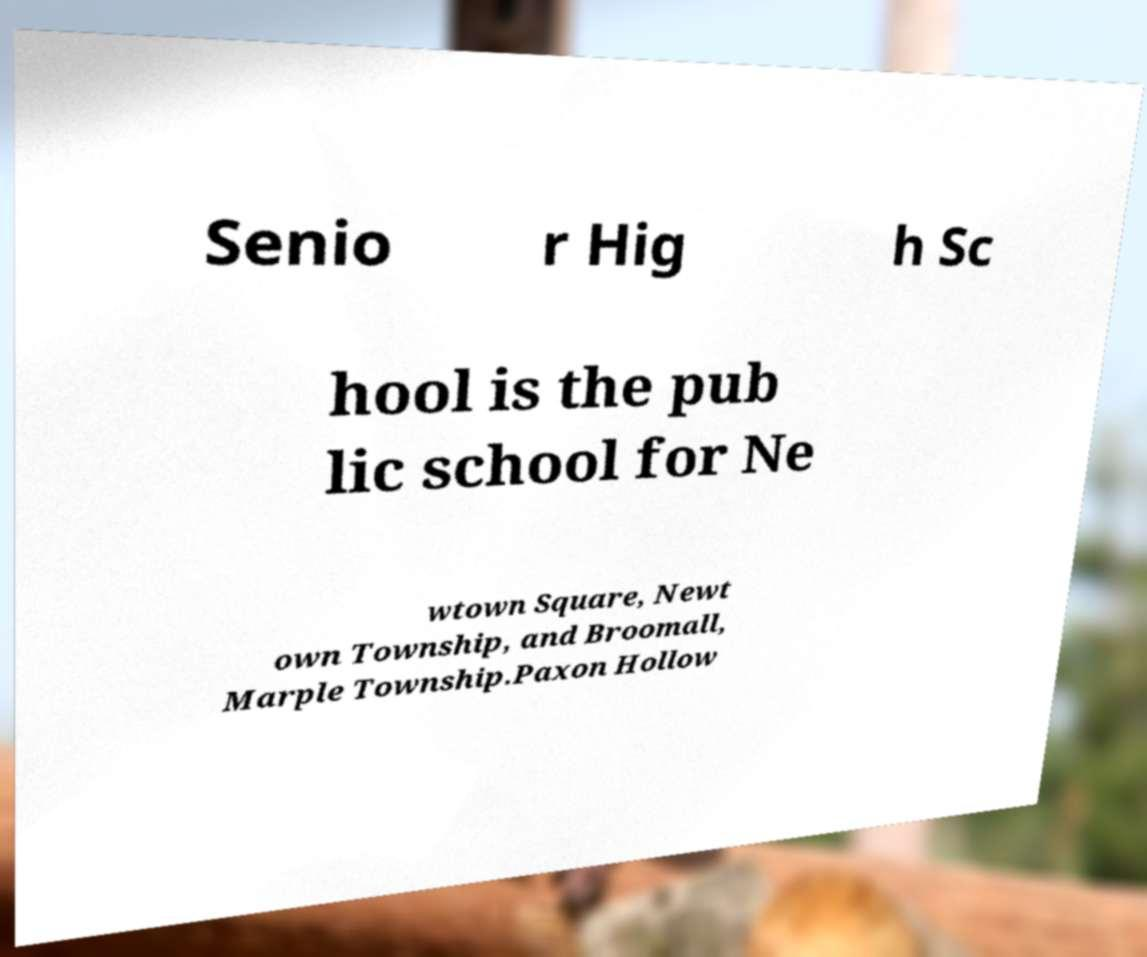Could you extract and type out the text from this image? Senio r Hig h Sc hool is the pub lic school for Ne wtown Square, Newt own Township, and Broomall, Marple Township.Paxon Hollow 